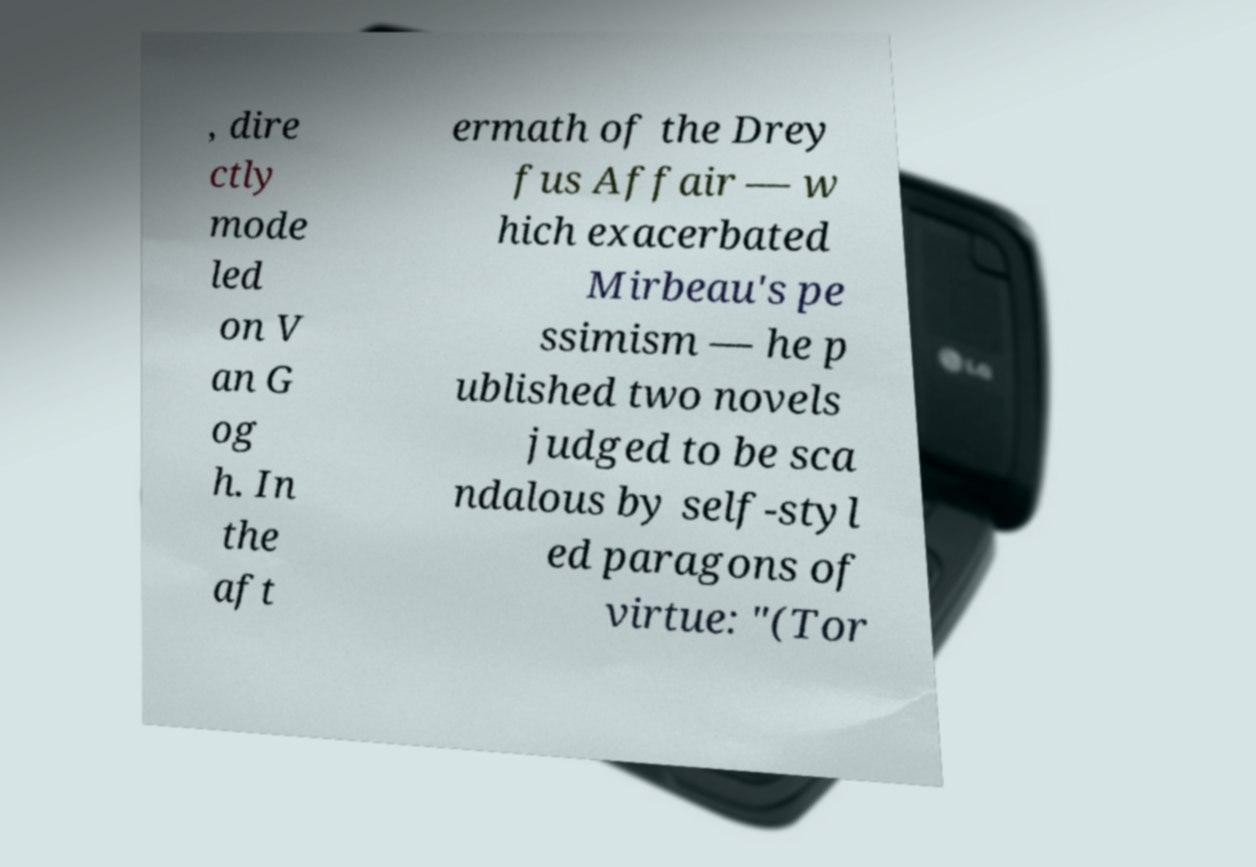What messages or text are displayed in this image? I need them in a readable, typed format. , dire ctly mode led on V an G og h. In the aft ermath of the Drey fus Affair — w hich exacerbated Mirbeau's pe ssimism — he p ublished two novels judged to be sca ndalous by self-styl ed paragons of virtue: "(Tor 